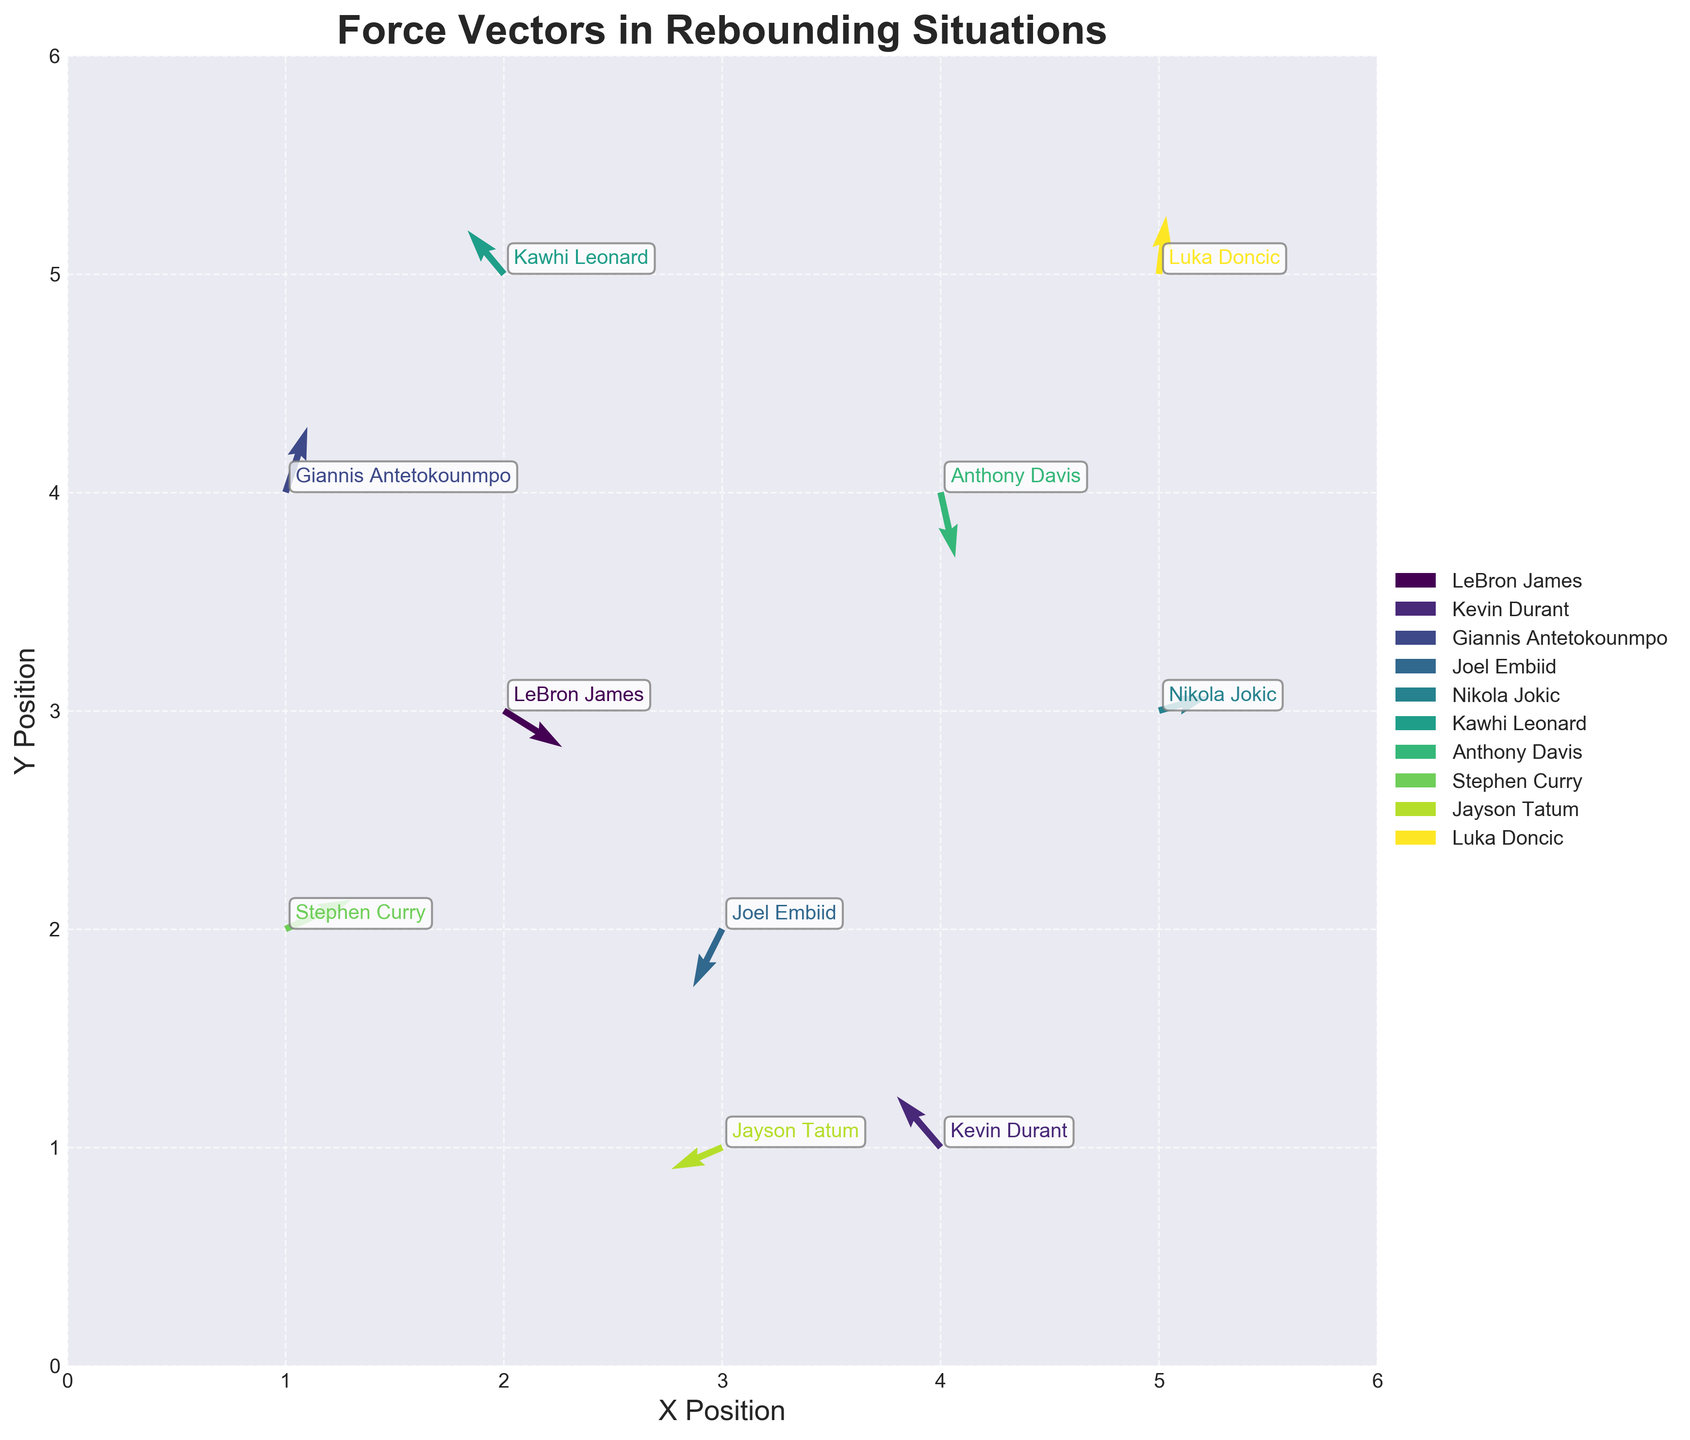What is the title of the figure? The title is displayed at the top of the plot, indicating the overall theme of the figure.
Answer: Force Vectors in Rebounding Situations How many players are represented in the figure? Each data point corresponds to a player, and their names are annotated next to them. Count the players' names listed.
Answer: 10 Who is the player located at (2,3)? Look at the coordinates (2,3) on the plot and find the player's name that is annotated at that position.
Answer: LeBron James Which player has the force vector with the smallest magnitude? Calculate the magnitude of each force vector with the formula sqrt(u^2 + v^2) and compare them.
Answer: Jayson Tatum Which player exerts a force vector primarily in the upward direction? Identify vectors where the v-component is positive and larger in magnitude compared to the u-component.
Answer: Giannis Antetokounmpo What is the direction of Kawhi Leonard's force vector? Look at Kawhi Leonard's vector (u, v), and determine the direction based on the positive or negative values of u and v.
Answer: Up-right Who has the force vector pointing mostly to the left? Identify vectors where the u-component is negative and larger in magnitude compared to the v-component.
Answer: Kevin Durant Which players’ force vectors are pointing downward? Find vectors where the v-component is negative, indicating a downward force component.
Answer: LeBron James, Joel Embiid, Anthony Davis What is the sum of the x-components of the force vectors? Sum all the u-values of the vectors: 0.8 + (-0.6) + 0.3 + (-0.4) + 0.7 + (-0.5) + 0.2 + 0.9 + (-0.7) + 0.1
Answer: 0.8 Who has a force vector with a greater magnitude: Stephen Curry or Luka Doncic? Calculate the magnitude of each vector and compare: Stephen Curry with u=0.9, v=0.4 and Luka Doncic with u=0.1, v=0.8 using sqrt(u^2 + v^2)
Answer: Stephen Curry 